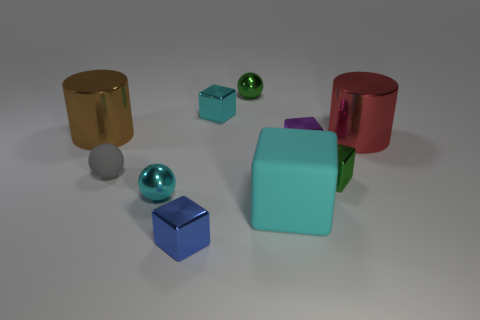Subtract all cyan metallic blocks. How many blocks are left? 4 Subtract all blue blocks. How many blocks are left? 4 Subtract 3 cubes. How many cubes are left? 2 Subtract all spheres. How many objects are left? 7 Subtract all brown blocks. Subtract all blue cylinders. How many blocks are left? 5 Subtract all red spheres. Subtract all tiny cyan shiny blocks. How many objects are left? 9 Add 9 large red metallic things. How many large red metallic things are left? 10 Add 4 tiny yellow matte things. How many tiny yellow matte things exist? 4 Subtract 0 cyan cylinders. How many objects are left? 10 